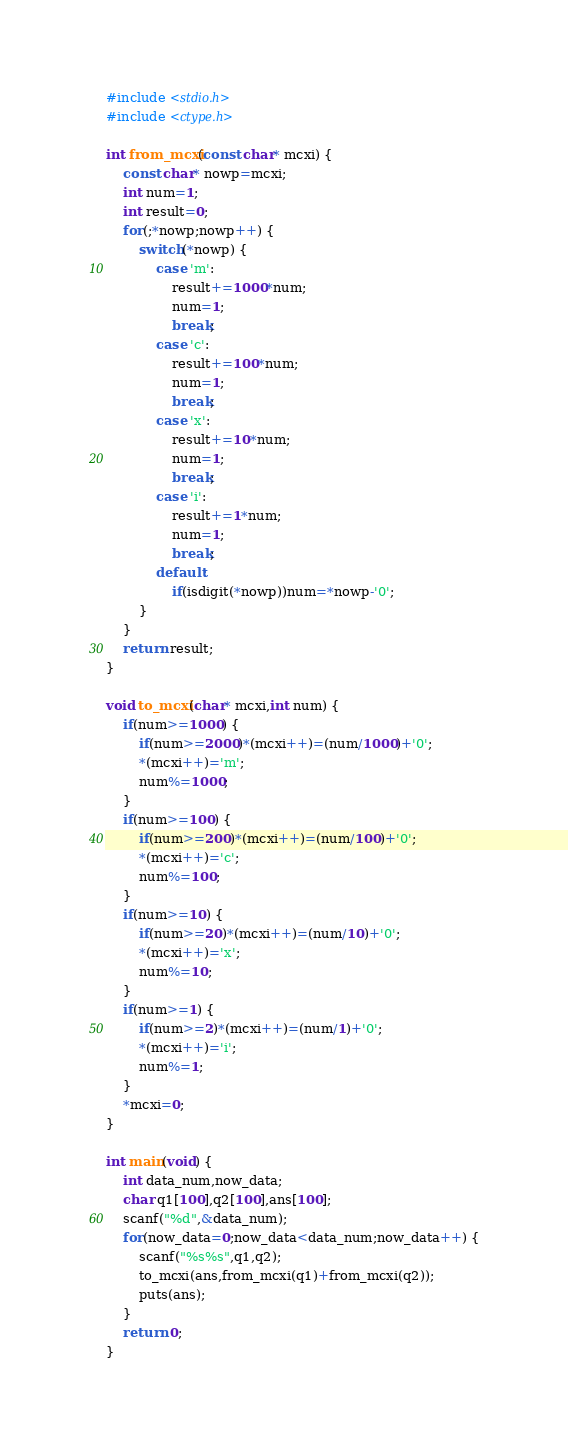Convert code to text. <code><loc_0><loc_0><loc_500><loc_500><_C_>#include <stdio.h>
#include <ctype.h>

int from_mcxi(const char* mcxi) {
	const char* nowp=mcxi;
	int num=1;
	int result=0;
	for(;*nowp;nowp++) {
		switch(*nowp) {
			case 'm':
				result+=1000*num;
				num=1;
				break;
			case 'c':
				result+=100*num;
				num=1;
				break;
			case 'x':
				result+=10*num;
				num=1;
				break;
			case 'i':
				result+=1*num;
				num=1;
				break;
			default:
				if(isdigit(*nowp))num=*nowp-'0';
		}
	}
	return result;
}

void to_mcxi(char* mcxi,int num) {
	if(num>=1000) {
		if(num>=2000)*(mcxi++)=(num/1000)+'0';
		*(mcxi++)='m';
		num%=1000;
	}
	if(num>=100) {
		if(num>=200)*(mcxi++)=(num/100)+'0';
		*(mcxi++)='c';
		num%=100;
	}
	if(num>=10) {
		if(num>=20)*(mcxi++)=(num/10)+'0';
		*(mcxi++)='x';
		num%=10;
	}
	if(num>=1) {
		if(num>=2)*(mcxi++)=(num/1)+'0';
		*(mcxi++)='i';
		num%=1;
	}
	*mcxi=0;
}

int main(void) {
	int data_num,now_data;
	char q1[100],q2[100],ans[100];
	scanf("%d",&data_num);
	for(now_data=0;now_data<data_num;now_data++) {
		scanf("%s%s",q1,q2);
		to_mcxi(ans,from_mcxi(q1)+from_mcxi(q2));
		puts(ans);
	}
	return 0;
}</code> 